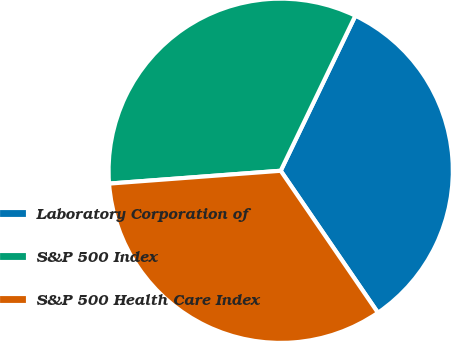Convert chart to OTSL. <chart><loc_0><loc_0><loc_500><loc_500><pie_chart><fcel>Laboratory Corporation of<fcel>S&P 500 Index<fcel>S&P 500 Health Care Index<nl><fcel>33.3%<fcel>33.33%<fcel>33.37%<nl></chart> 